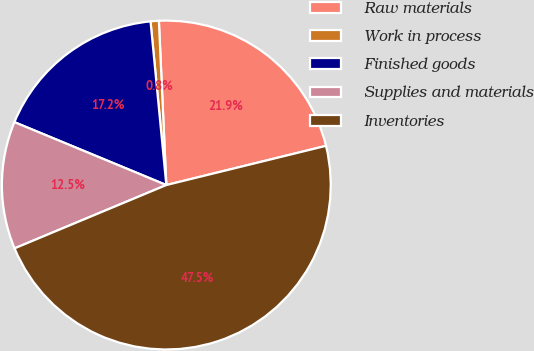Convert chart to OTSL. <chart><loc_0><loc_0><loc_500><loc_500><pie_chart><fcel>Raw materials<fcel>Work in process<fcel>Finished goods<fcel>Supplies and materials<fcel>Inventories<nl><fcel>21.89%<fcel>0.81%<fcel>17.22%<fcel>12.54%<fcel>47.54%<nl></chart> 